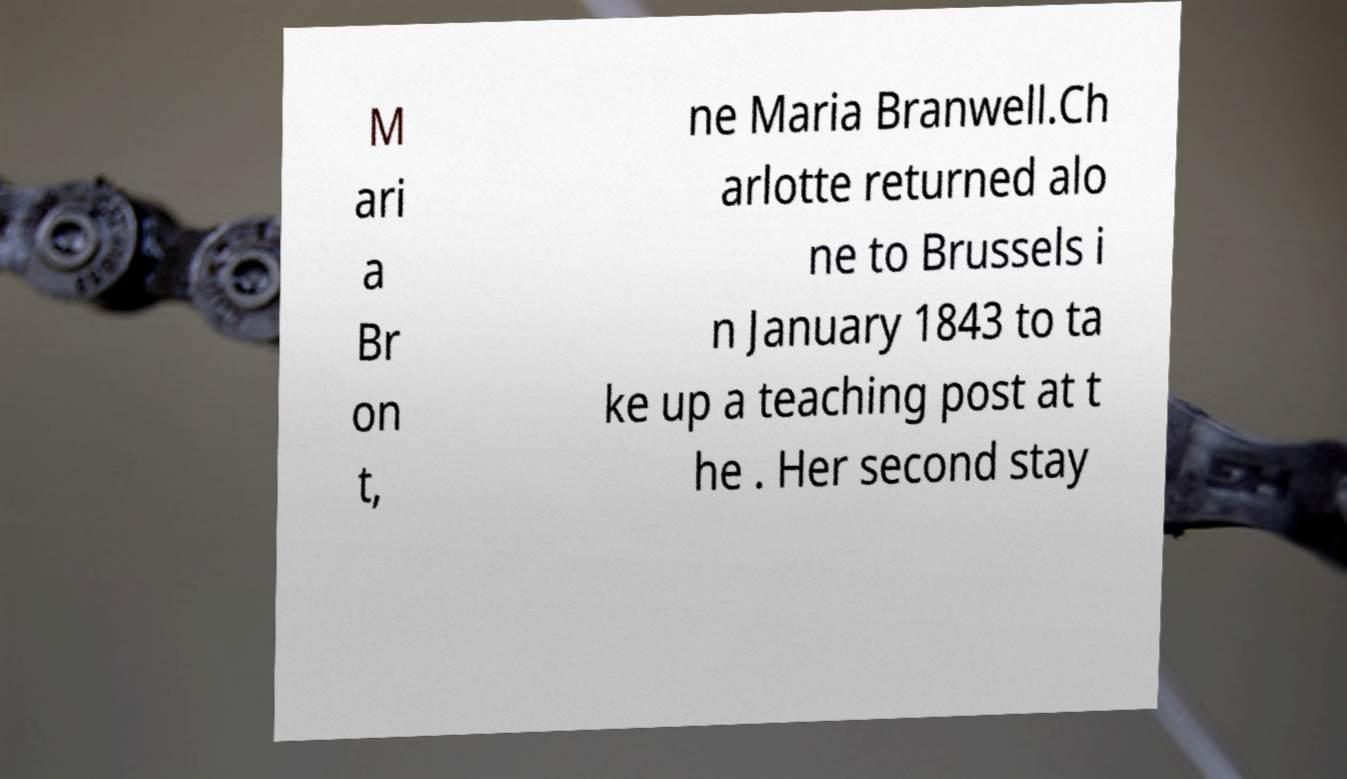Please identify and transcribe the text found in this image. M ari a Br on t, ne Maria Branwell.Ch arlotte returned alo ne to Brussels i n January 1843 to ta ke up a teaching post at t he . Her second stay 